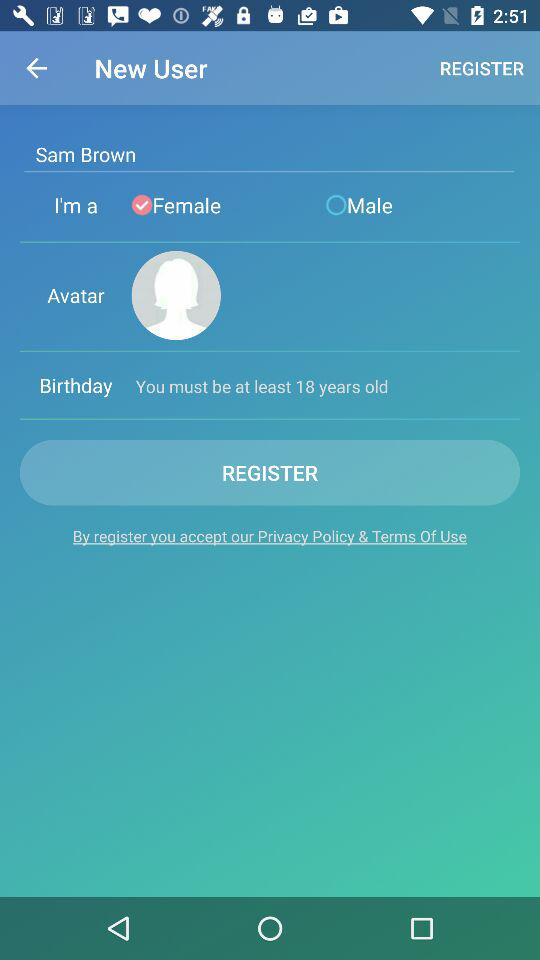What is the name of the user? The name of the user is Sam Brown. 